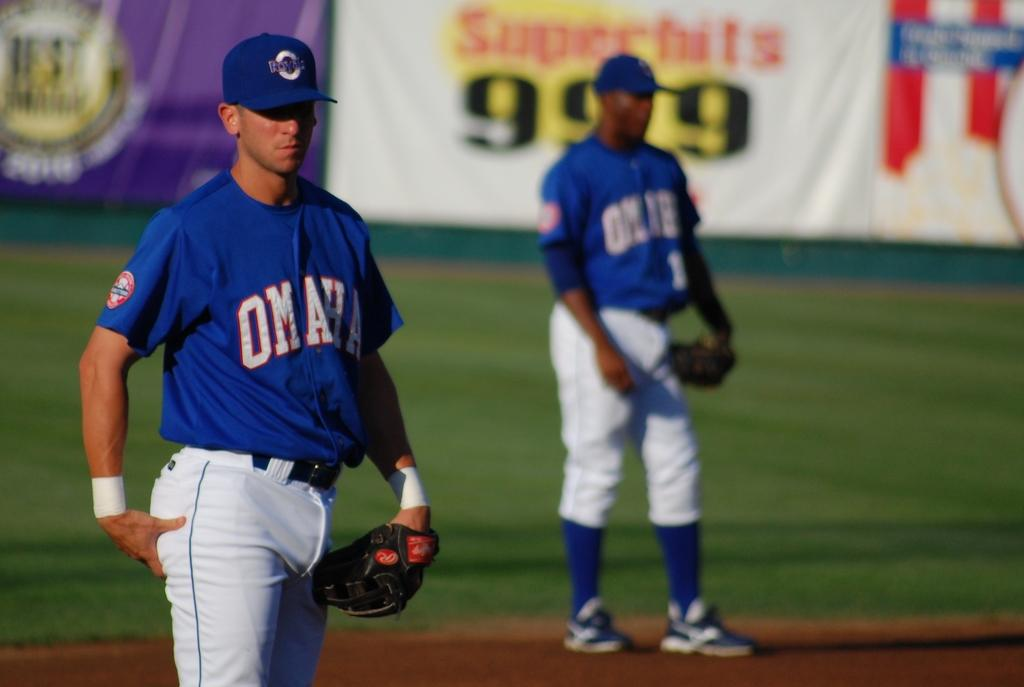<image>
Provide a brief description of the given image. A baseball player with the word Omaha on his shirt 